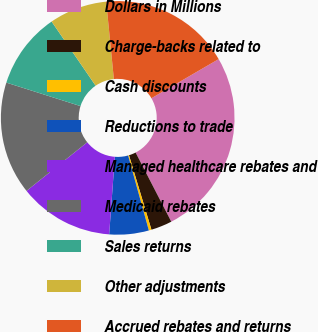Convert chart. <chart><loc_0><loc_0><loc_500><loc_500><pie_chart><fcel>Dollars in Millions<fcel>Charge-backs related to<fcel>Cash discounts<fcel>Reductions to trade<fcel>Managed healthcare rebates and<fcel>Medicaid rebates<fcel>Sales returns<fcel>Other adjustments<fcel>Accrued rebates and returns<nl><fcel>25.81%<fcel>2.92%<fcel>0.37%<fcel>5.46%<fcel>13.09%<fcel>15.63%<fcel>10.55%<fcel>8.0%<fcel>18.18%<nl></chart> 